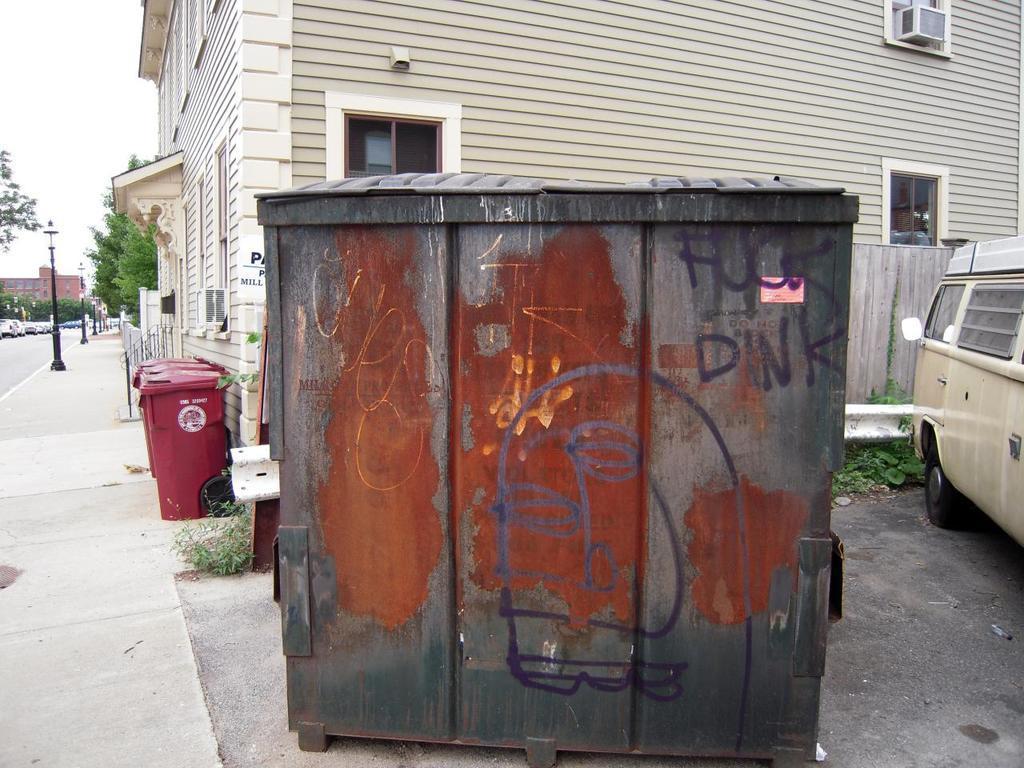Please provide a concise description of this image. In this picture we can see some text on a wooden object, car, street lights and dust bin is visible on the path. There are a few trees and buildings visible in the background. 